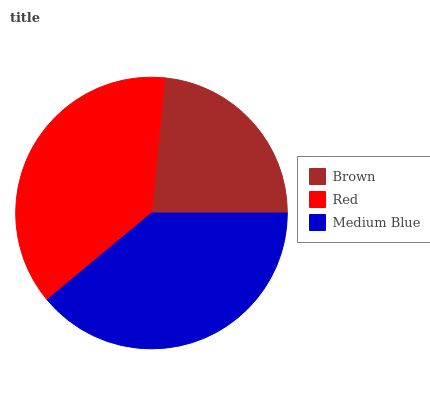Is Brown the minimum?
Answer yes or no. Yes. Is Medium Blue the maximum?
Answer yes or no. Yes. Is Red the minimum?
Answer yes or no. No. Is Red the maximum?
Answer yes or no. No. Is Red greater than Brown?
Answer yes or no. Yes. Is Brown less than Red?
Answer yes or no. Yes. Is Brown greater than Red?
Answer yes or no. No. Is Red less than Brown?
Answer yes or no. No. Is Red the high median?
Answer yes or no. Yes. Is Red the low median?
Answer yes or no. Yes. Is Medium Blue the high median?
Answer yes or no. No. Is Brown the low median?
Answer yes or no. No. 